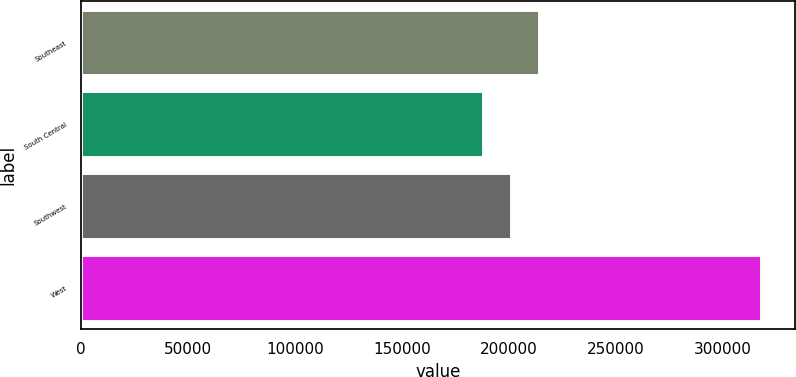Convert chart. <chart><loc_0><loc_0><loc_500><loc_500><bar_chart><fcel>Southeast<fcel>South Central<fcel>Southwest<fcel>West<nl><fcel>213940<fcel>188000<fcel>200970<fcel>317700<nl></chart> 